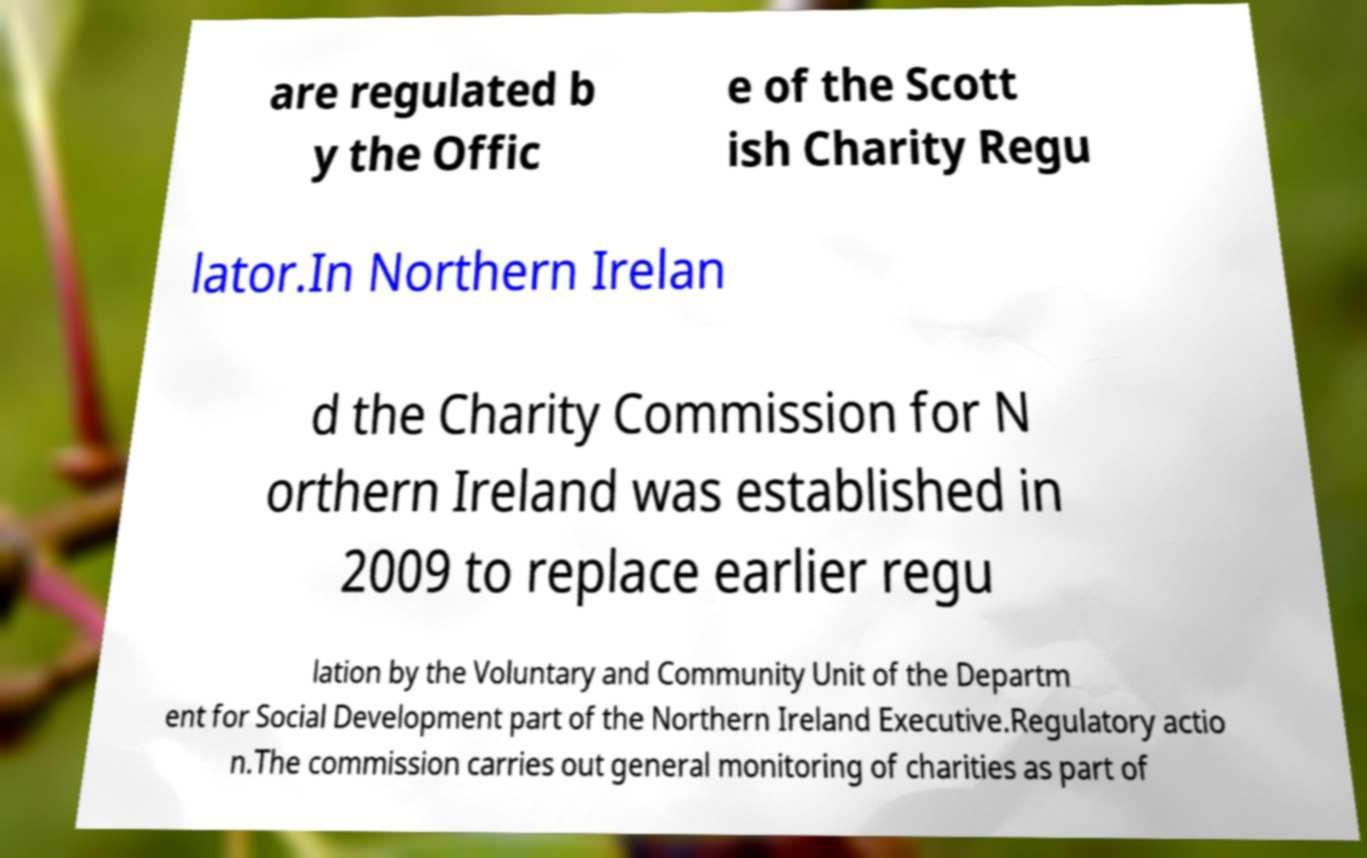Could you extract and type out the text from this image? are regulated b y the Offic e of the Scott ish Charity Regu lator.In Northern Irelan d the Charity Commission for N orthern Ireland was established in 2009 to replace earlier regu lation by the Voluntary and Community Unit of the Departm ent for Social Development part of the Northern Ireland Executive.Regulatory actio n.The commission carries out general monitoring of charities as part of 